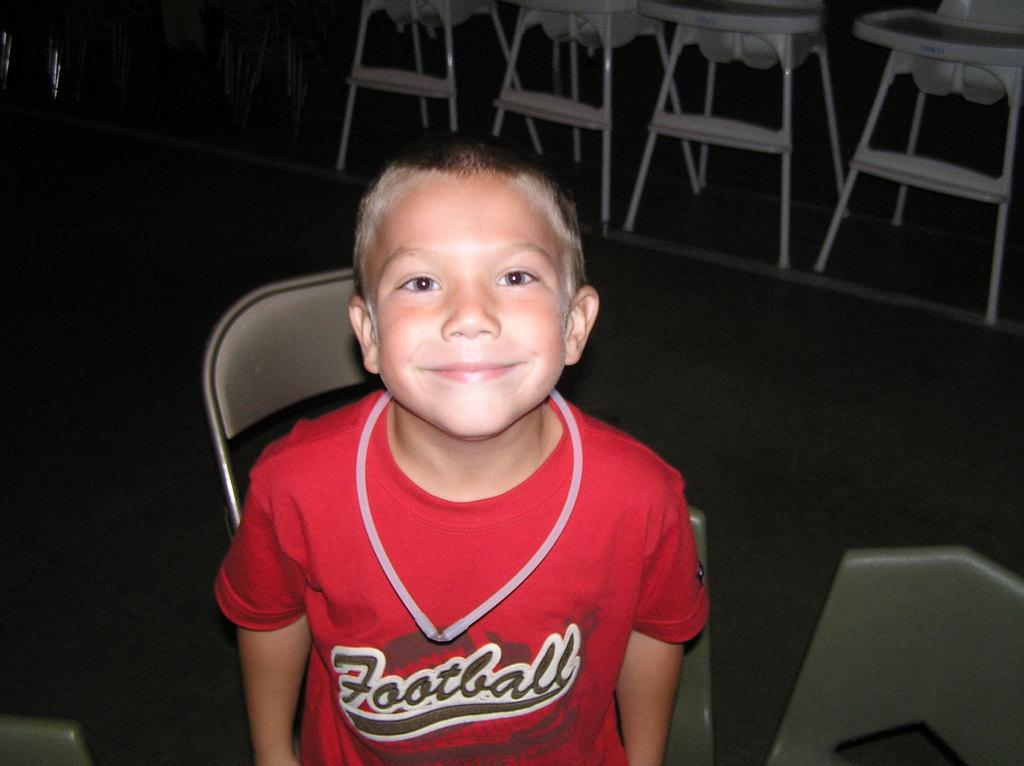<image>
Present a compact description of the photo's key features. the word football is on the boy's jersey 